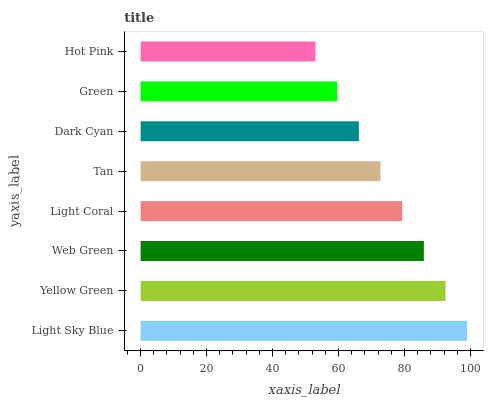Is Hot Pink the minimum?
Answer yes or no. Yes. Is Light Sky Blue the maximum?
Answer yes or no. Yes. Is Yellow Green the minimum?
Answer yes or no. No. Is Yellow Green the maximum?
Answer yes or no. No. Is Light Sky Blue greater than Yellow Green?
Answer yes or no. Yes. Is Yellow Green less than Light Sky Blue?
Answer yes or no. Yes. Is Yellow Green greater than Light Sky Blue?
Answer yes or no. No. Is Light Sky Blue less than Yellow Green?
Answer yes or no. No. Is Light Coral the high median?
Answer yes or no. Yes. Is Tan the low median?
Answer yes or no. Yes. Is Green the high median?
Answer yes or no. No. Is Hot Pink the low median?
Answer yes or no. No. 